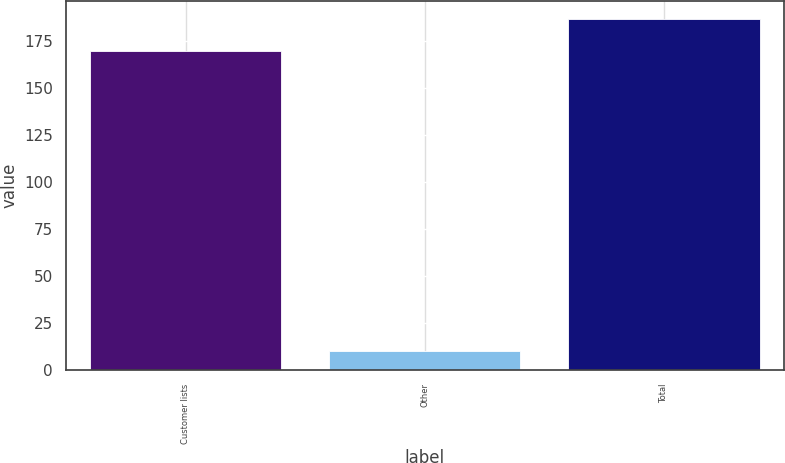Convert chart to OTSL. <chart><loc_0><loc_0><loc_500><loc_500><bar_chart><fcel>Customer lists<fcel>Other<fcel>Total<nl><fcel>170<fcel>10<fcel>187<nl></chart> 